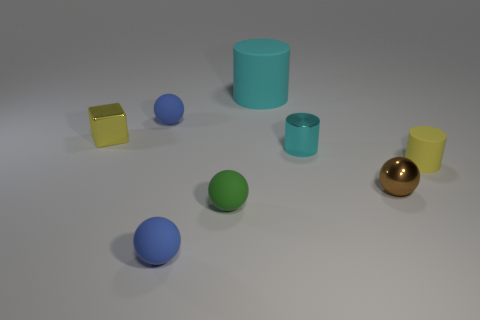There is a small sphere behind the yellow object left of the large thing; what color is it? The small sphere situated behind the yellow object, to the left of the larger cylindrical shape, is blue. It appears to be one of several colorful spheres in this group of objects. 